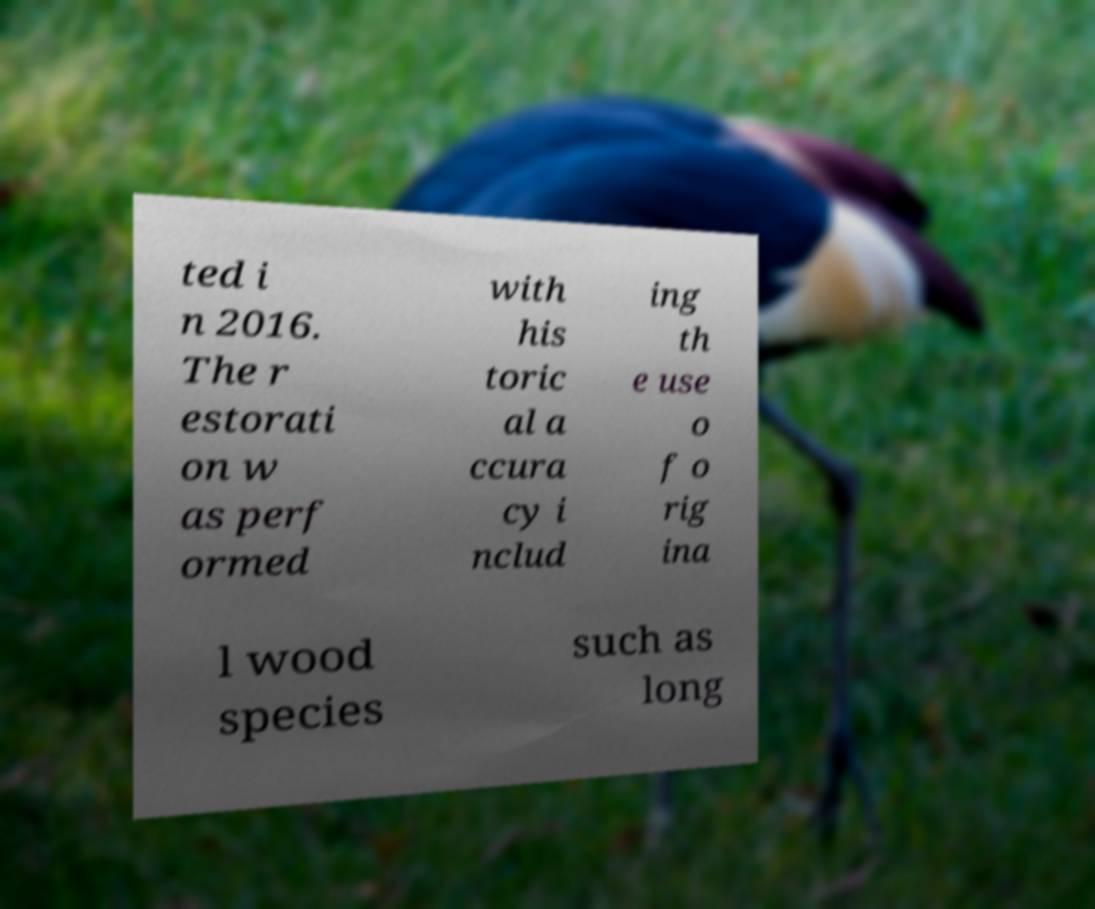There's text embedded in this image that I need extracted. Can you transcribe it verbatim? ted i n 2016. The r estorati on w as perf ormed with his toric al a ccura cy i nclud ing th e use o f o rig ina l wood species such as long 